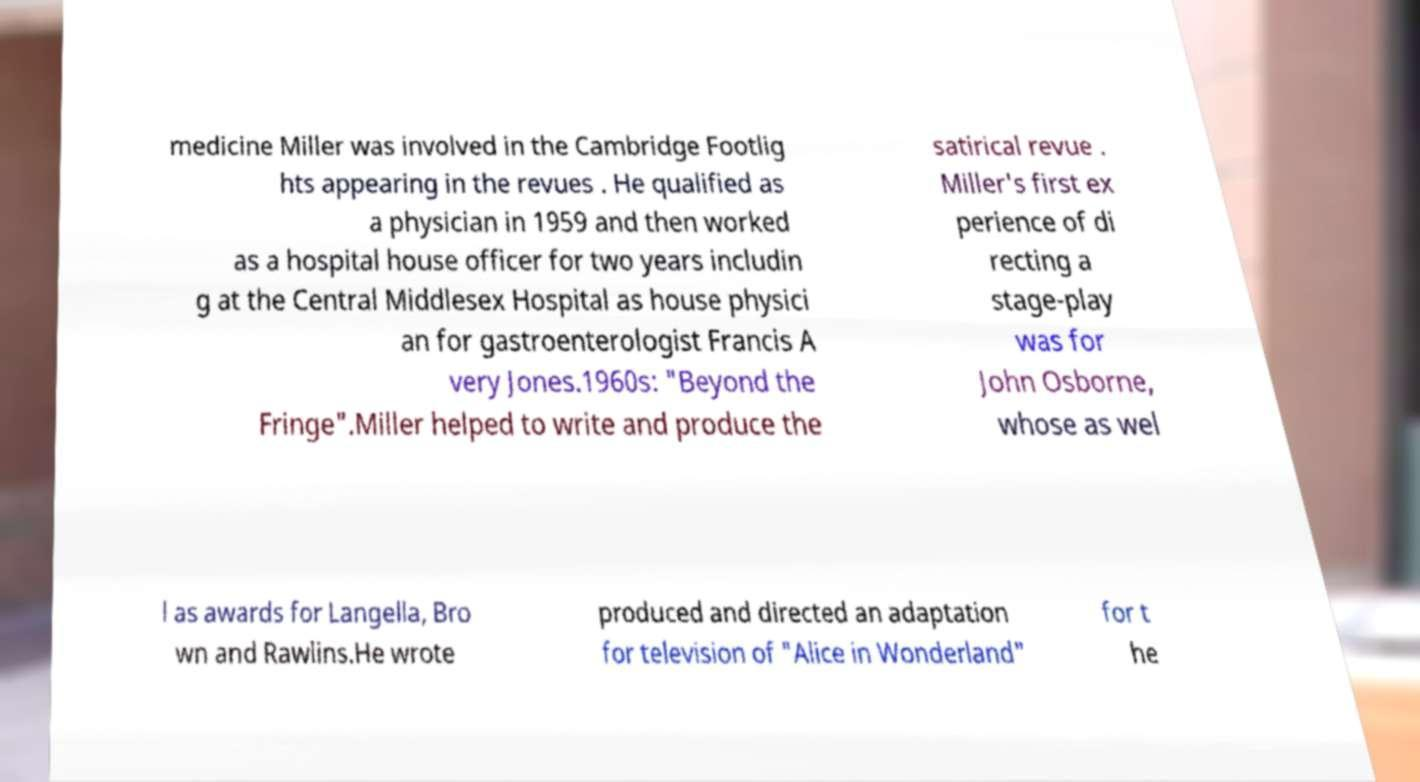Can you read and provide the text displayed in the image?This photo seems to have some interesting text. Can you extract and type it out for me? medicine Miller was involved in the Cambridge Footlig hts appearing in the revues . He qualified as a physician in 1959 and then worked as a hospital house officer for two years includin g at the Central Middlesex Hospital as house physici an for gastroenterologist Francis A very Jones.1960s: "Beyond the Fringe".Miller helped to write and produce the satirical revue . Miller's first ex perience of di recting a stage-play was for John Osborne, whose as wel l as awards for Langella, Bro wn and Rawlins.He wrote produced and directed an adaptation for television of "Alice in Wonderland" for t he 